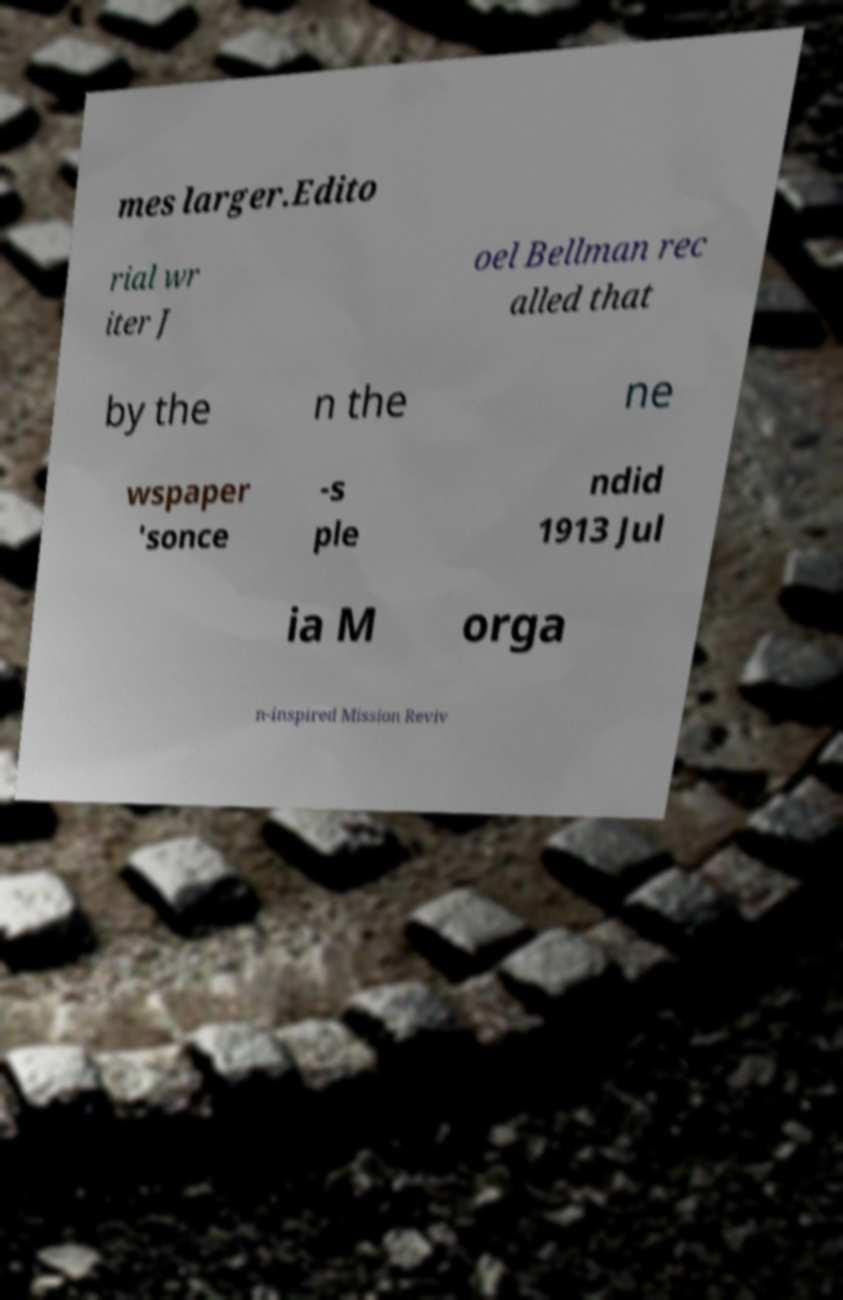Can you read and provide the text displayed in the image?This photo seems to have some interesting text. Can you extract and type it out for me? mes larger.Edito rial wr iter J oel Bellman rec alled that by the n the ne wspaper 'sonce -s ple ndid 1913 Jul ia M orga n-inspired Mission Reviv 